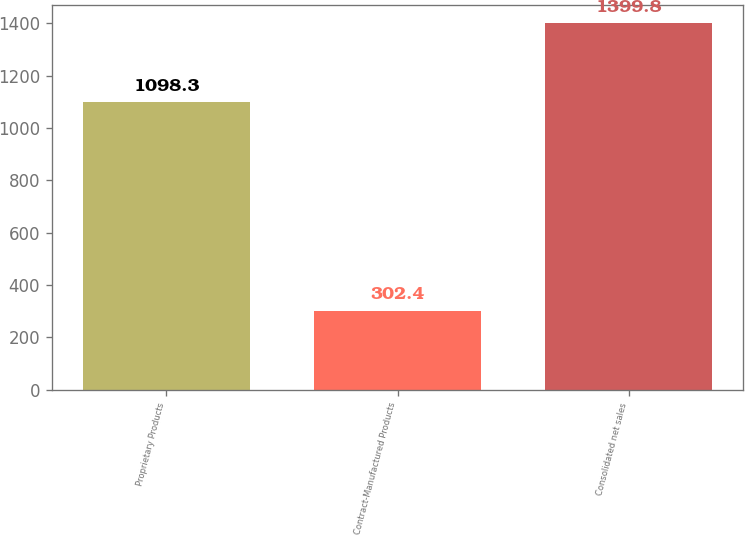Convert chart. <chart><loc_0><loc_0><loc_500><loc_500><bar_chart><fcel>Proprietary Products<fcel>Contract-Manufactured Products<fcel>Consolidated net sales<nl><fcel>1098.3<fcel>302.4<fcel>1399.8<nl></chart> 